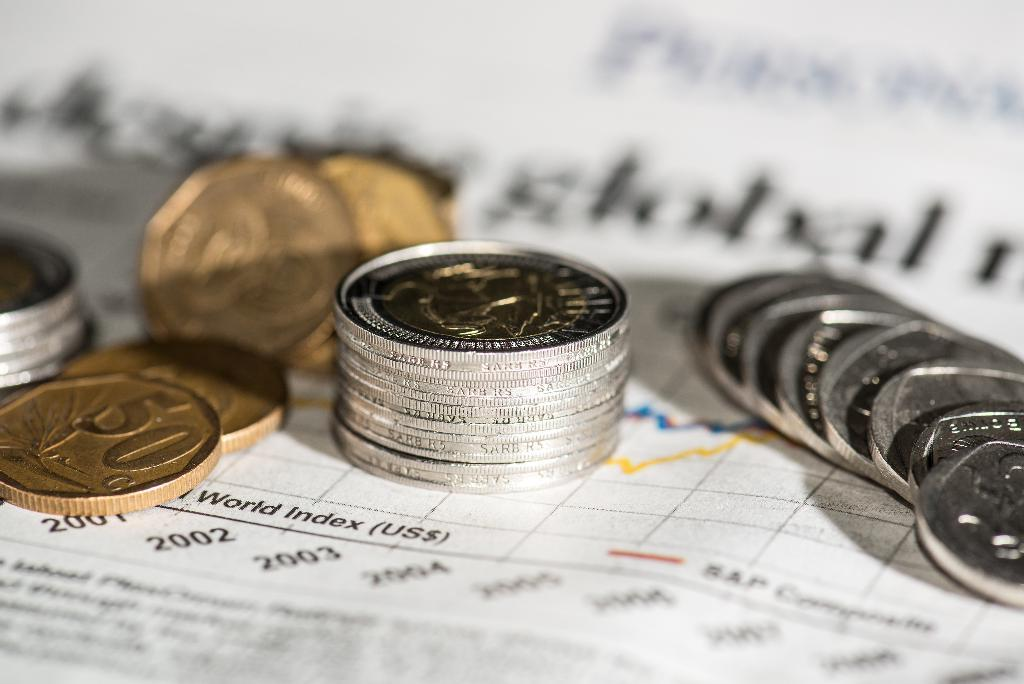<image>
Give a short and clear explanation of the subsequent image. Foreign currency on a newspaper with the world index on it 